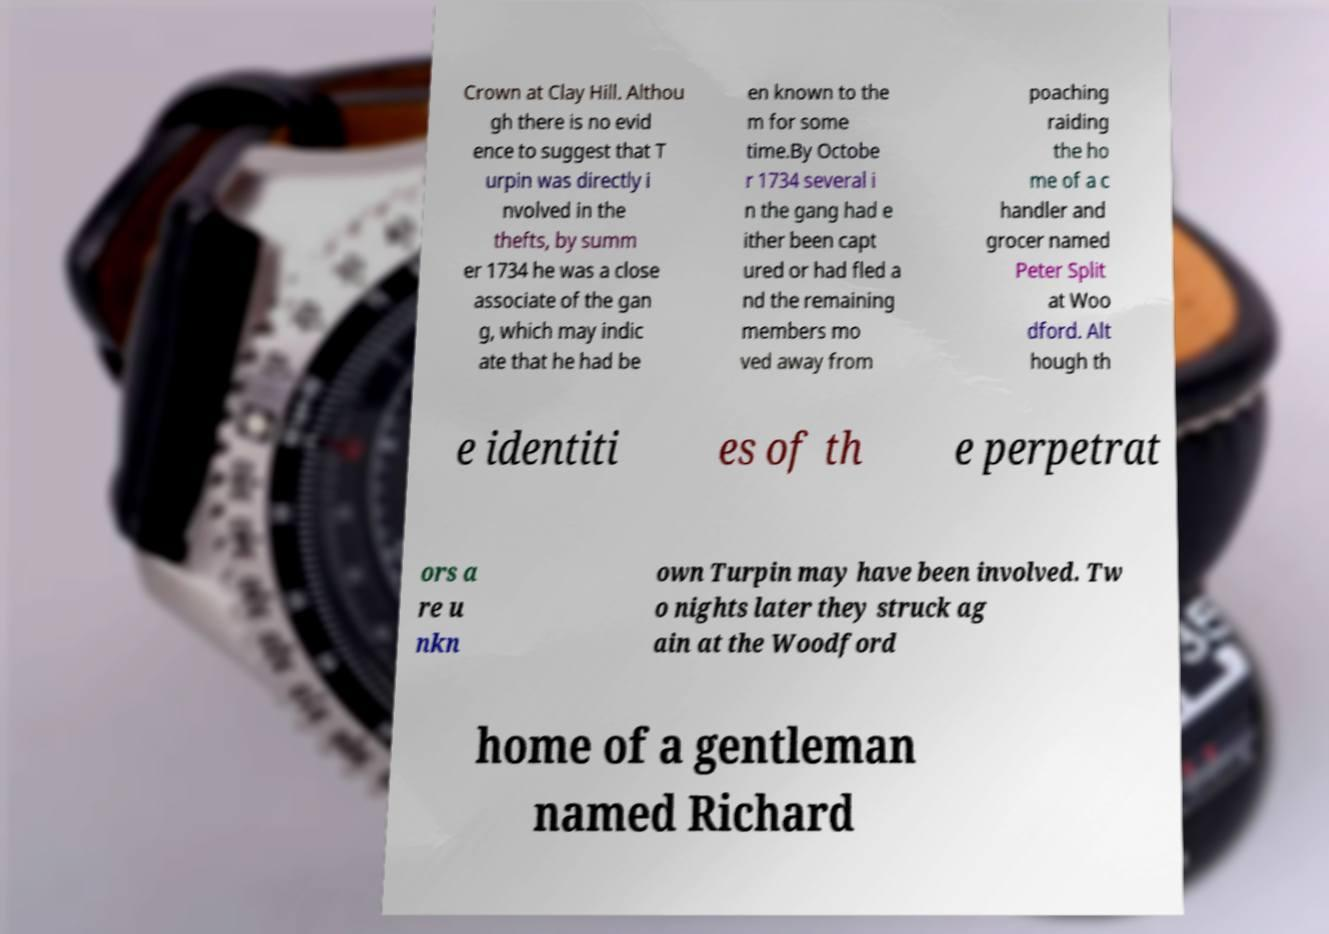Please identify and transcribe the text found in this image. Crown at Clay Hill. Althou gh there is no evid ence to suggest that T urpin was directly i nvolved in the thefts, by summ er 1734 he was a close associate of the gan g, which may indic ate that he had be en known to the m for some time.By Octobe r 1734 several i n the gang had e ither been capt ured or had fled a nd the remaining members mo ved away from poaching raiding the ho me of a c handler and grocer named Peter Split at Woo dford. Alt hough th e identiti es of th e perpetrat ors a re u nkn own Turpin may have been involved. Tw o nights later they struck ag ain at the Woodford home of a gentleman named Richard 